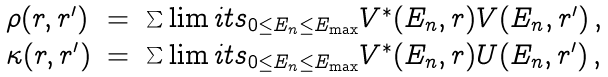Convert formula to latex. <formula><loc_0><loc_0><loc_500><loc_500>\begin{array} { l l l } \rho ( { r } , { r } ^ { \prime } ) & = & \sum \lim i t s _ { 0 \leq E _ { n } \leq E _ { \max } } V ^ { \ast } ( E _ { n } , { r } ) V ( E _ { n } , { r } ^ { \prime } ) \, , \\ \kappa ( { r } , { r } ^ { \prime } ) & = & \sum \lim i t s _ { 0 \leq E _ { n } \leq E _ { \max } } V ^ { \ast } ( E _ { n } , { r } ) U ( E _ { n } , { r } ^ { \prime } ) \, , \end{array}</formula> 